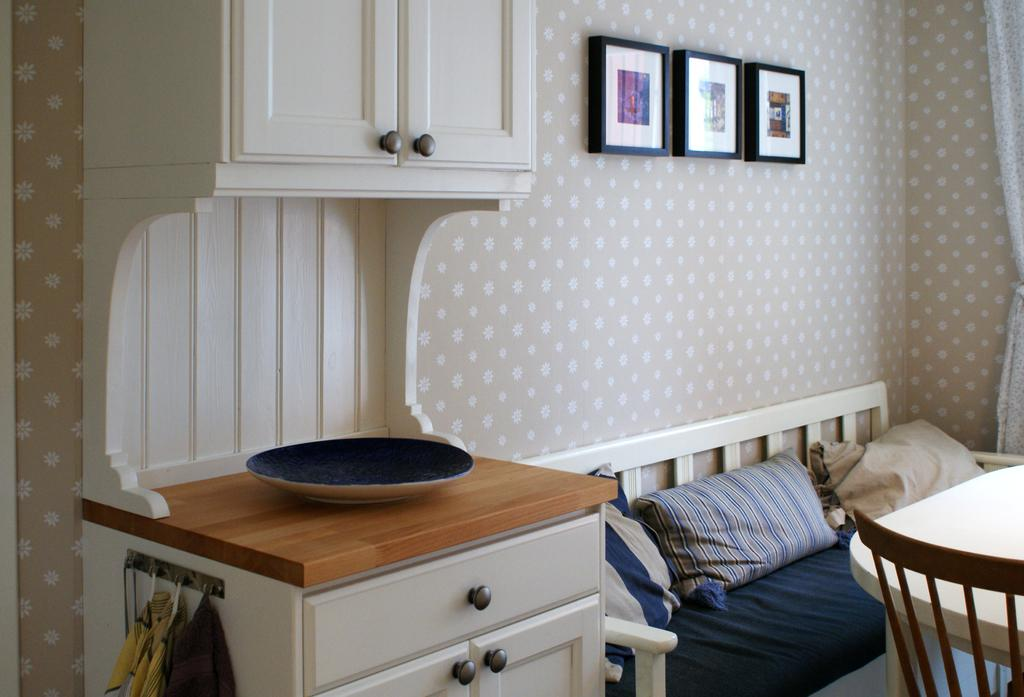What type of space is depicted in the image? There is a room in the image. What type of seating is available in the room? There are cushions and chairs in the room. What type of furniture is present in the room? There are tables and cupboards in the room. What type of decorations are in the room? There are frames in the room. What type of silk is draped over the toe of the chair in the image? There is no silk or reference to a toe in the image; it only shows a room with cushions, tables, chairs, cupboards, and frames. 